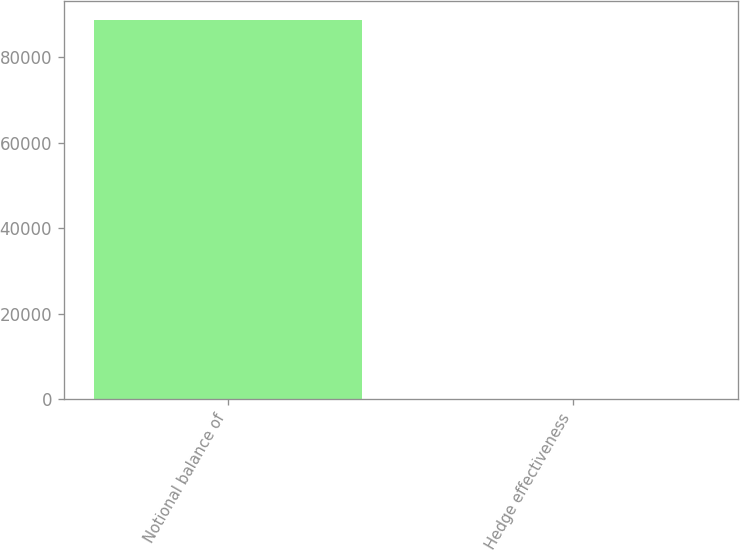<chart> <loc_0><loc_0><loc_500><loc_500><bar_chart><fcel>Notional balance of<fcel>Hedge effectiveness<nl><fcel>88680<fcel>100<nl></chart> 